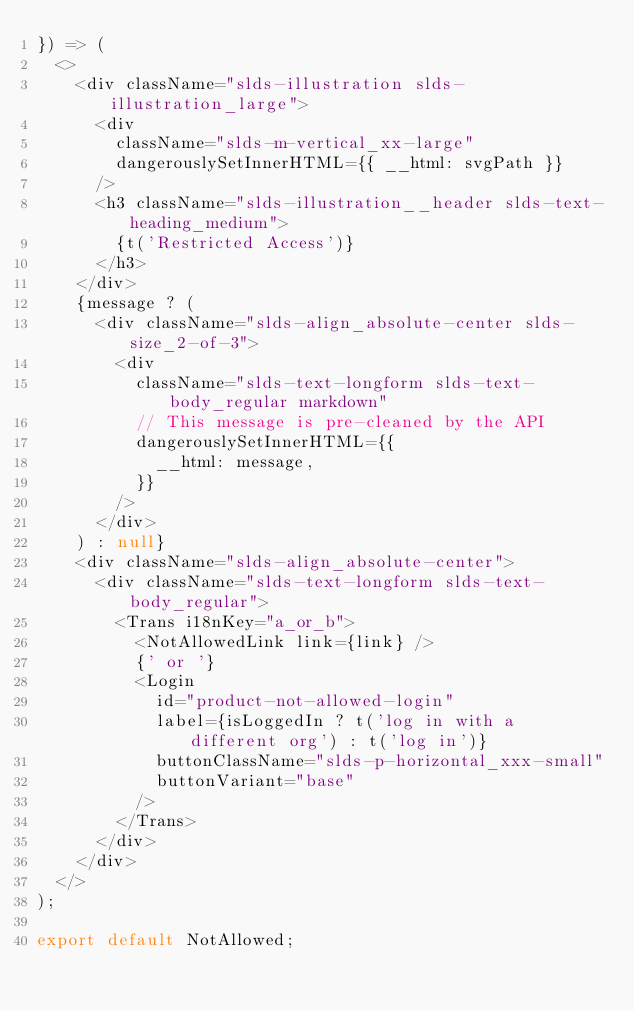<code> <loc_0><loc_0><loc_500><loc_500><_TypeScript_>}) => (
  <>
    <div className="slds-illustration slds-illustration_large">
      <div
        className="slds-m-vertical_xx-large"
        dangerouslySetInnerHTML={{ __html: svgPath }}
      />
      <h3 className="slds-illustration__header slds-text-heading_medium">
        {t('Restricted Access')}
      </h3>
    </div>
    {message ? (
      <div className="slds-align_absolute-center slds-size_2-of-3">
        <div
          className="slds-text-longform slds-text-body_regular markdown"
          // This message is pre-cleaned by the API
          dangerouslySetInnerHTML={{
            __html: message,
          }}
        />
      </div>
    ) : null}
    <div className="slds-align_absolute-center">
      <div className="slds-text-longform slds-text-body_regular">
        <Trans i18nKey="a_or_b">
          <NotAllowedLink link={link} />
          {' or '}
          <Login
            id="product-not-allowed-login"
            label={isLoggedIn ? t('log in with a different org') : t('log in')}
            buttonClassName="slds-p-horizontal_xxx-small"
            buttonVariant="base"
          />
        </Trans>
      </div>
    </div>
  </>
);

export default NotAllowed;
</code> 